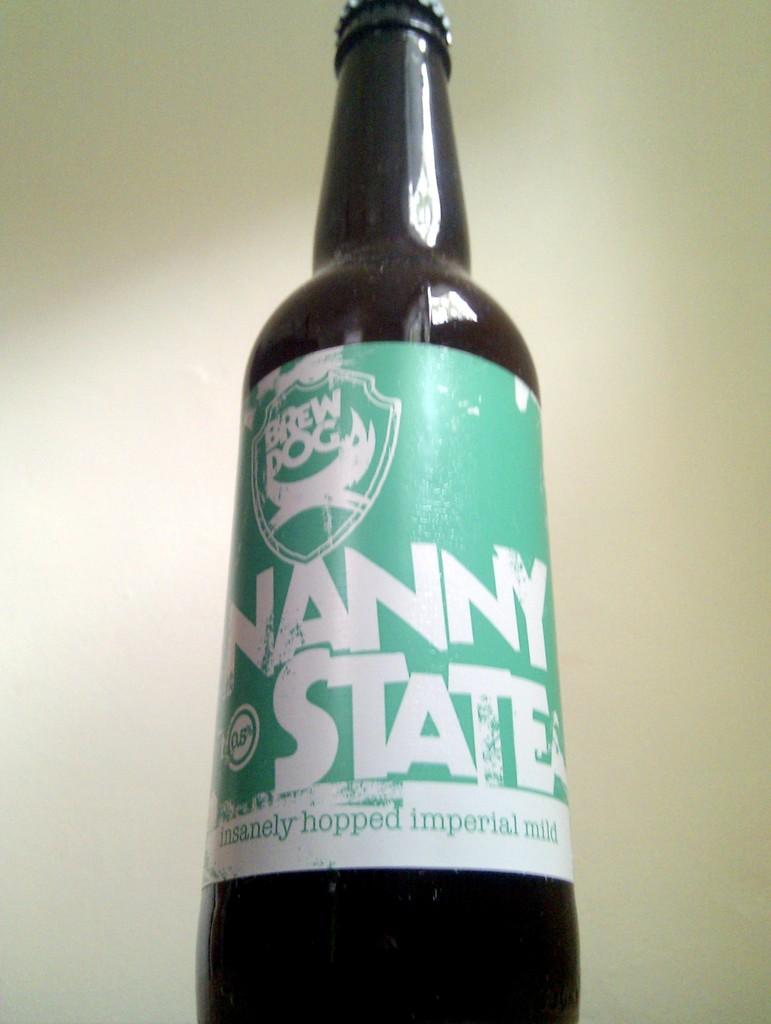What kind of beer is this?
Give a very brief answer. Nanny state. What company brewed this beer?
Offer a terse response. Brew dog. 